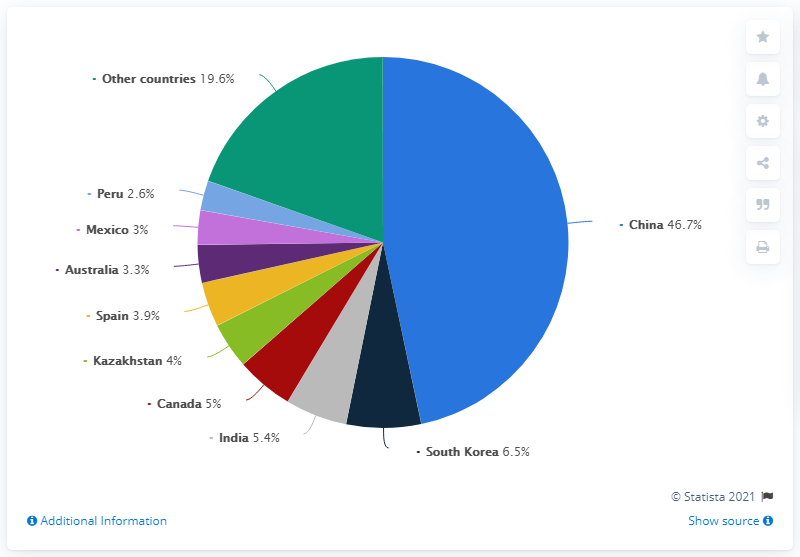Point out several critical features in this image. The chart indicates that South Korea is the second most dominant country. In 2019, China produced 46.7% of the world's zinc production. According to data from 2019, China was the globe's leading manufacturer of refined zinc. According to the data, China is significantly larger than South Korea, with a GDP per capita ratio of 40.2%. 